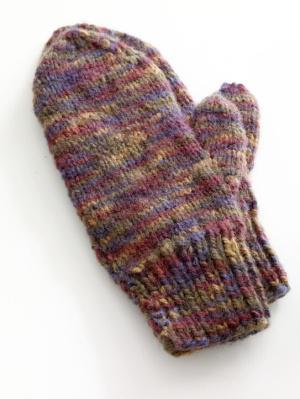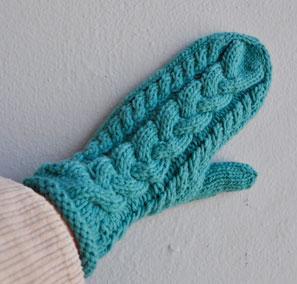The first image is the image on the left, the second image is the image on the right. Analyze the images presented: Is the assertion "One pair of mittons has a visible animal design knitted in, and the other pair does not." valid? Answer yes or no. No. 